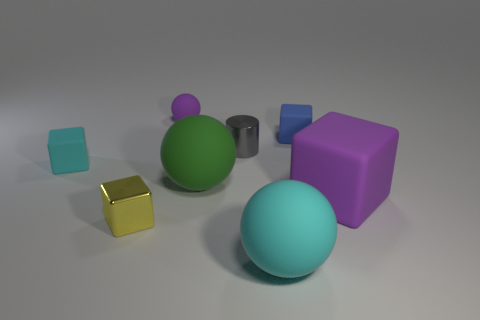Add 1 purple matte cubes. How many objects exist? 9 Subtract all cylinders. How many objects are left? 7 Add 1 blue matte cubes. How many blue matte cubes exist? 2 Subtract 0 purple cylinders. How many objects are left? 8 Subtract all large green matte spheres. Subtract all purple objects. How many objects are left? 5 Add 3 blue rubber cubes. How many blue rubber cubes are left? 4 